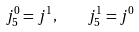<formula> <loc_0><loc_0><loc_500><loc_500>j _ { 5 } ^ { 0 } = j ^ { 1 } , \quad j _ { 5 } ^ { 1 } = j ^ { 0 }</formula> 